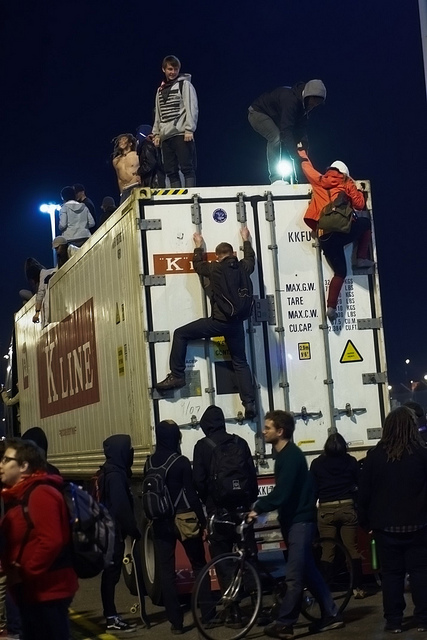Why might people be drawn to climb the container? People might be drawn to climb the container for a variety of reasons, such as curiosity, the challenge of climbing, the thrill of reaching the top, or even as part of a protest or artistic expression if this is a public event. Is there any significance to this location? The presence of a shipping container in what seems to be a public space could signify a temporary event, an art installation, or a gathering spot for a specific community or movement. The context of the image doesn't provide details, but these factors often attract attention and engagement. 